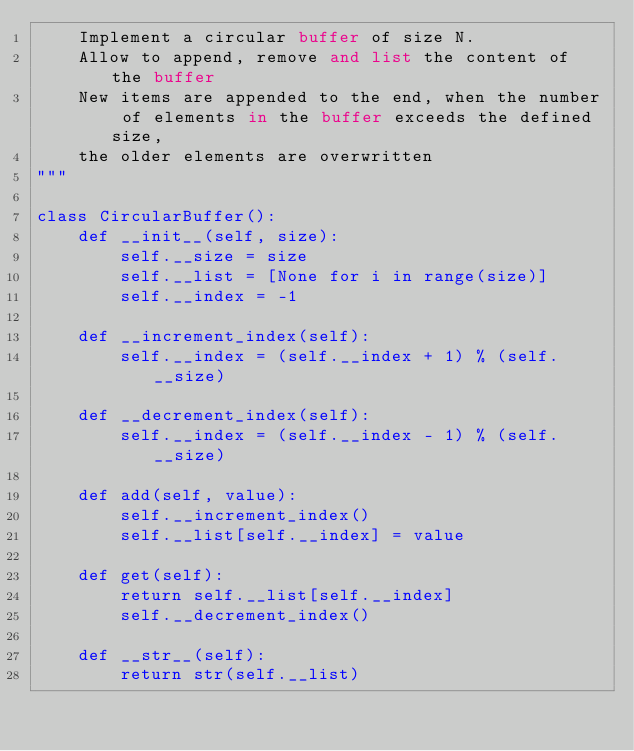Convert code to text. <code><loc_0><loc_0><loc_500><loc_500><_Python_>    Implement a circular buffer of size N. 
    Allow to append, remove and list the content of the buffer
    New items are appended to the end, when the number of elements in the buffer exceeds the defined size, 
    the older elements are overwritten
"""

class CircularBuffer():
    def __init__(self, size):
        self.__size = size
        self.__list = [None for i in range(size)]
        self.__index = -1

    def __increment_index(self):
        self.__index = (self.__index + 1) % (self.__size)

    def __decrement_index(self):
        self.__index = (self.__index - 1) % (self.__size)

    def add(self, value):
        self.__increment_index()
        self.__list[self.__index] = value

    def get(self):
        return self.__list[self.__index]
        self.__decrement_index()

    def __str__(self):
        return str(self.__list)

</code> 